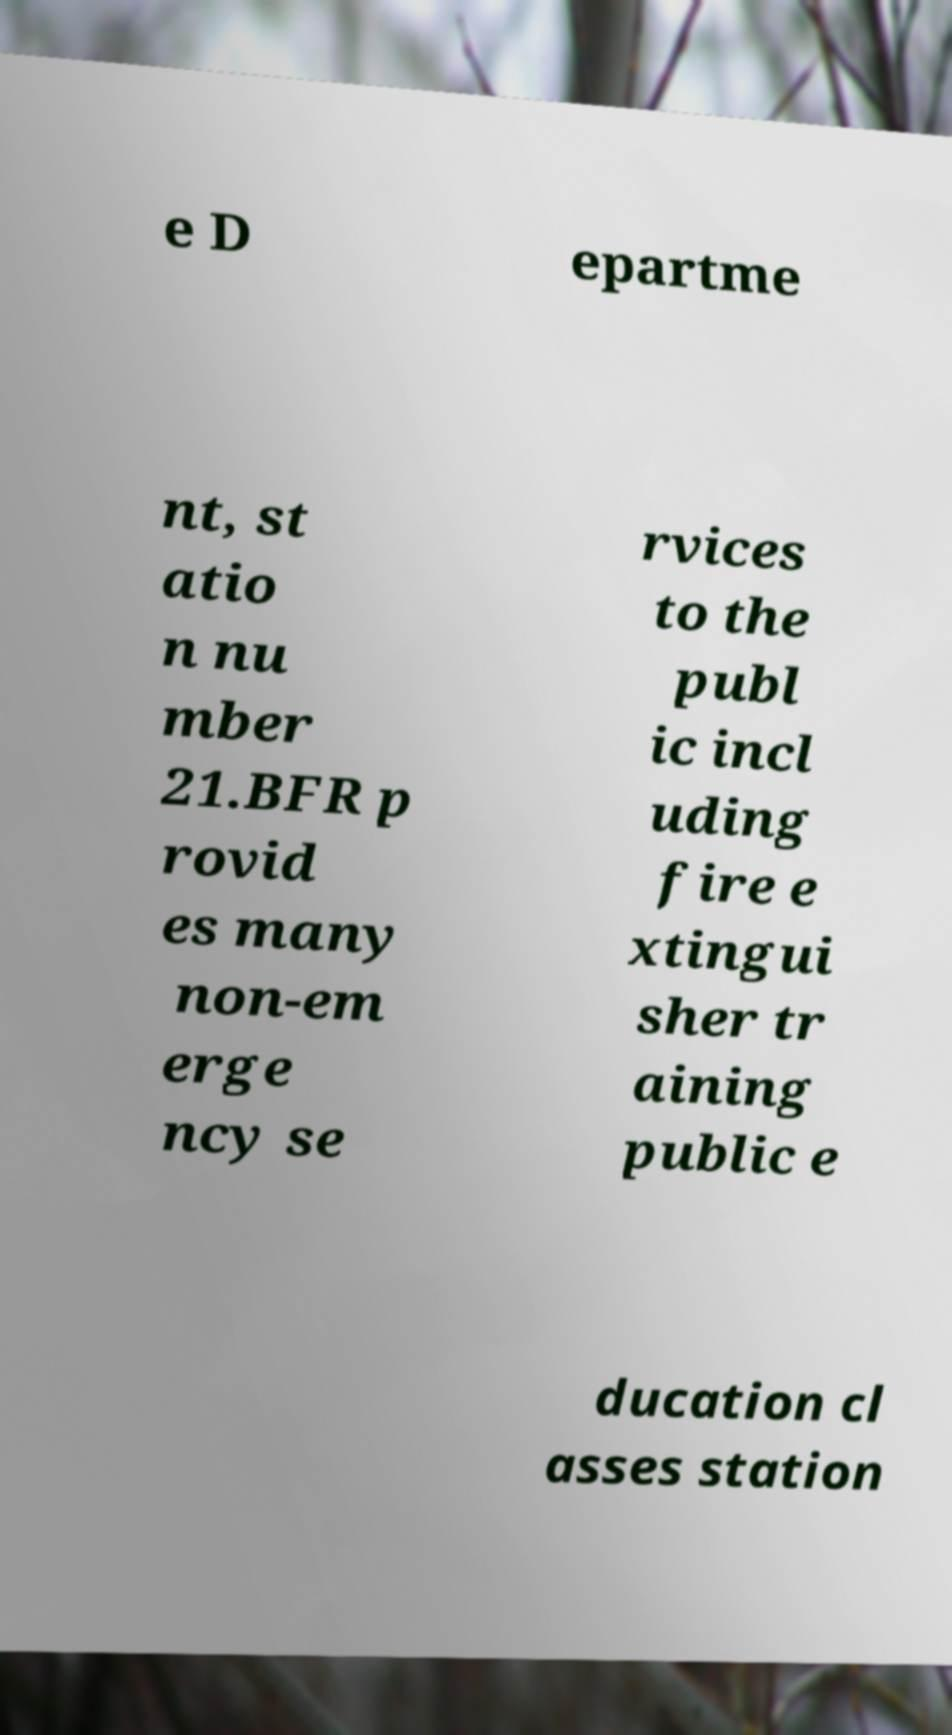For documentation purposes, I need the text within this image transcribed. Could you provide that? e D epartme nt, st atio n nu mber 21.BFR p rovid es many non-em erge ncy se rvices to the publ ic incl uding fire e xtingui sher tr aining public e ducation cl asses station 